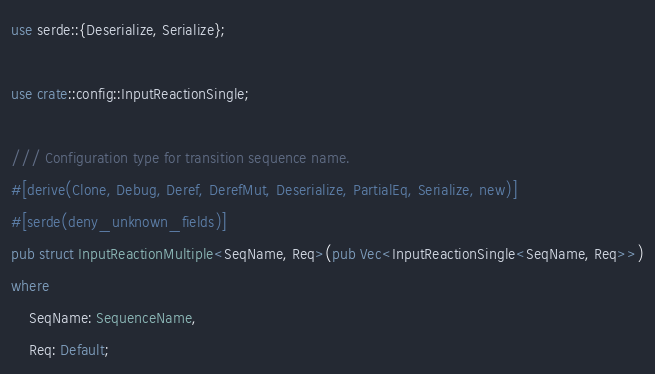<code> <loc_0><loc_0><loc_500><loc_500><_Rust_>use serde::{Deserialize, Serialize};

use crate::config::InputReactionSingle;

/// Configuration type for transition sequence name.
#[derive(Clone, Debug, Deref, DerefMut, Deserialize, PartialEq, Serialize, new)]
#[serde(deny_unknown_fields)]
pub struct InputReactionMultiple<SeqName, Req>(pub Vec<InputReactionSingle<SeqName, Req>>)
where
    SeqName: SequenceName,
    Req: Default;
</code> 